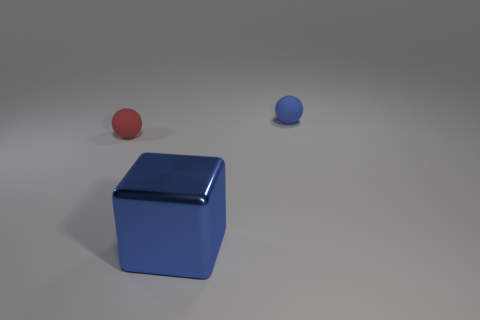There is a rubber object that is the same color as the large metallic thing; what is its size?
Ensure brevity in your answer.  Small. There is a tiny rubber thing right of the large shiny thing; does it have the same color as the object that is in front of the small red rubber thing?
Your answer should be compact. Yes. Are there any tiny blue objects that have the same shape as the small red object?
Ensure brevity in your answer.  Yes. What number of things are either matte balls or balls on the left side of the large blue cube?
Your response must be concise. 2. The rubber thing that is on the left side of the shiny block is what color?
Your response must be concise. Red. There is a matte thing that is to the right of the red ball; does it have the same size as the rubber sphere left of the large blue shiny object?
Your answer should be compact. Yes. Is there a matte sphere that has the same size as the blue metallic cube?
Give a very brief answer. No. There is a small ball that is to the left of the blue rubber ball; what number of metal blocks are in front of it?
Your answer should be very brief. 1. What is the material of the tiny red object?
Ensure brevity in your answer.  Rubber. What number of large objects are to the left of the red rubber sphere?
Your response must be concise. 0. 